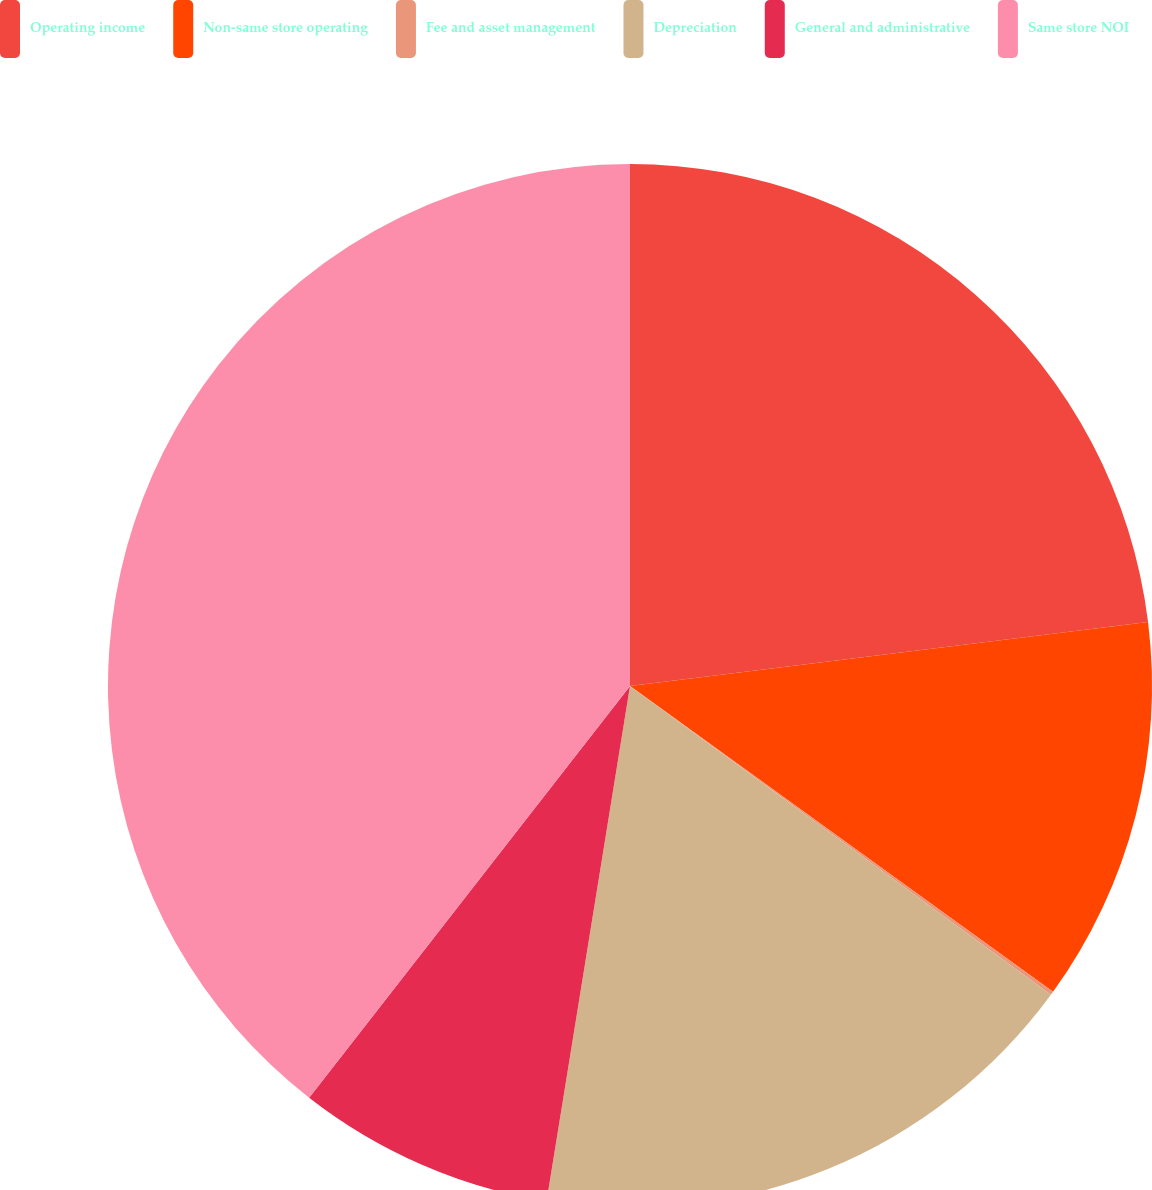<chart> <loc_0><loc_0><loc_500><loc_500><pie_chart><fcel>Operating income<fcel>Non-same store operating<fcel>Fee and asset management<fcel>Depreciation<fcel>General and administrative<fcel>Same store NOI<nl><fcel>23.04%<fcel>11.92%<fcel>0.11%<fcel>17.48%<fcel>7.98%<fcel>39.46%<nl></chart> 